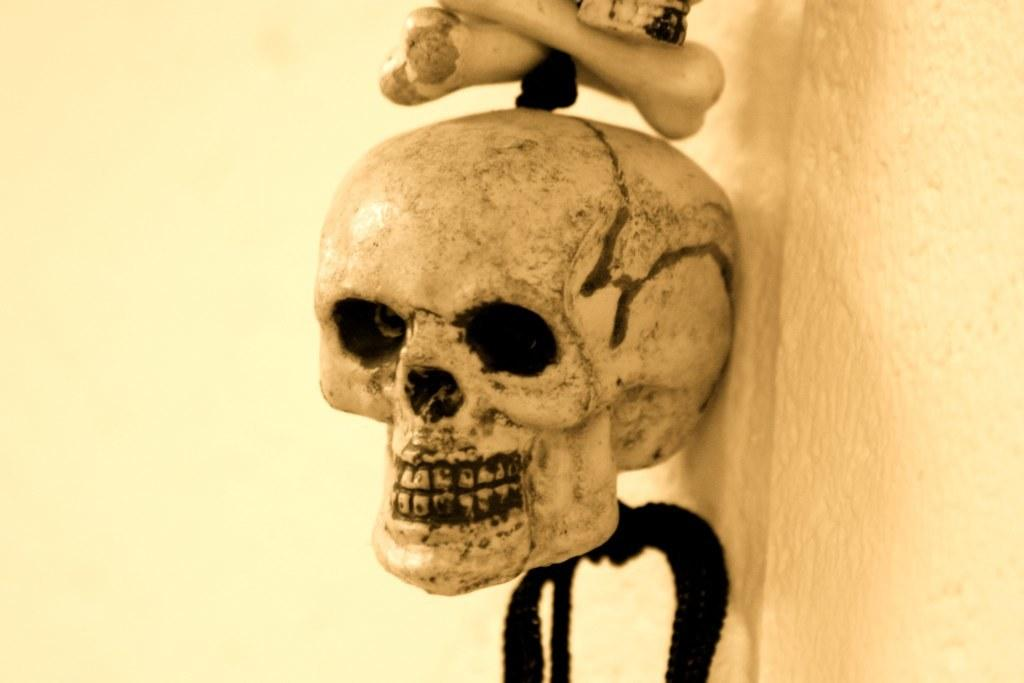What is the main object in the image? There is an artificial skull in the image. What other objects are present with the skull? There are bones in the image. How are the skull and bones connected? The skull and bones are attached with a black thread. What type of creature is thinking about the range of its habitat in the image? There is no creature present in the image, and no thoughts or habitats are depicted. 